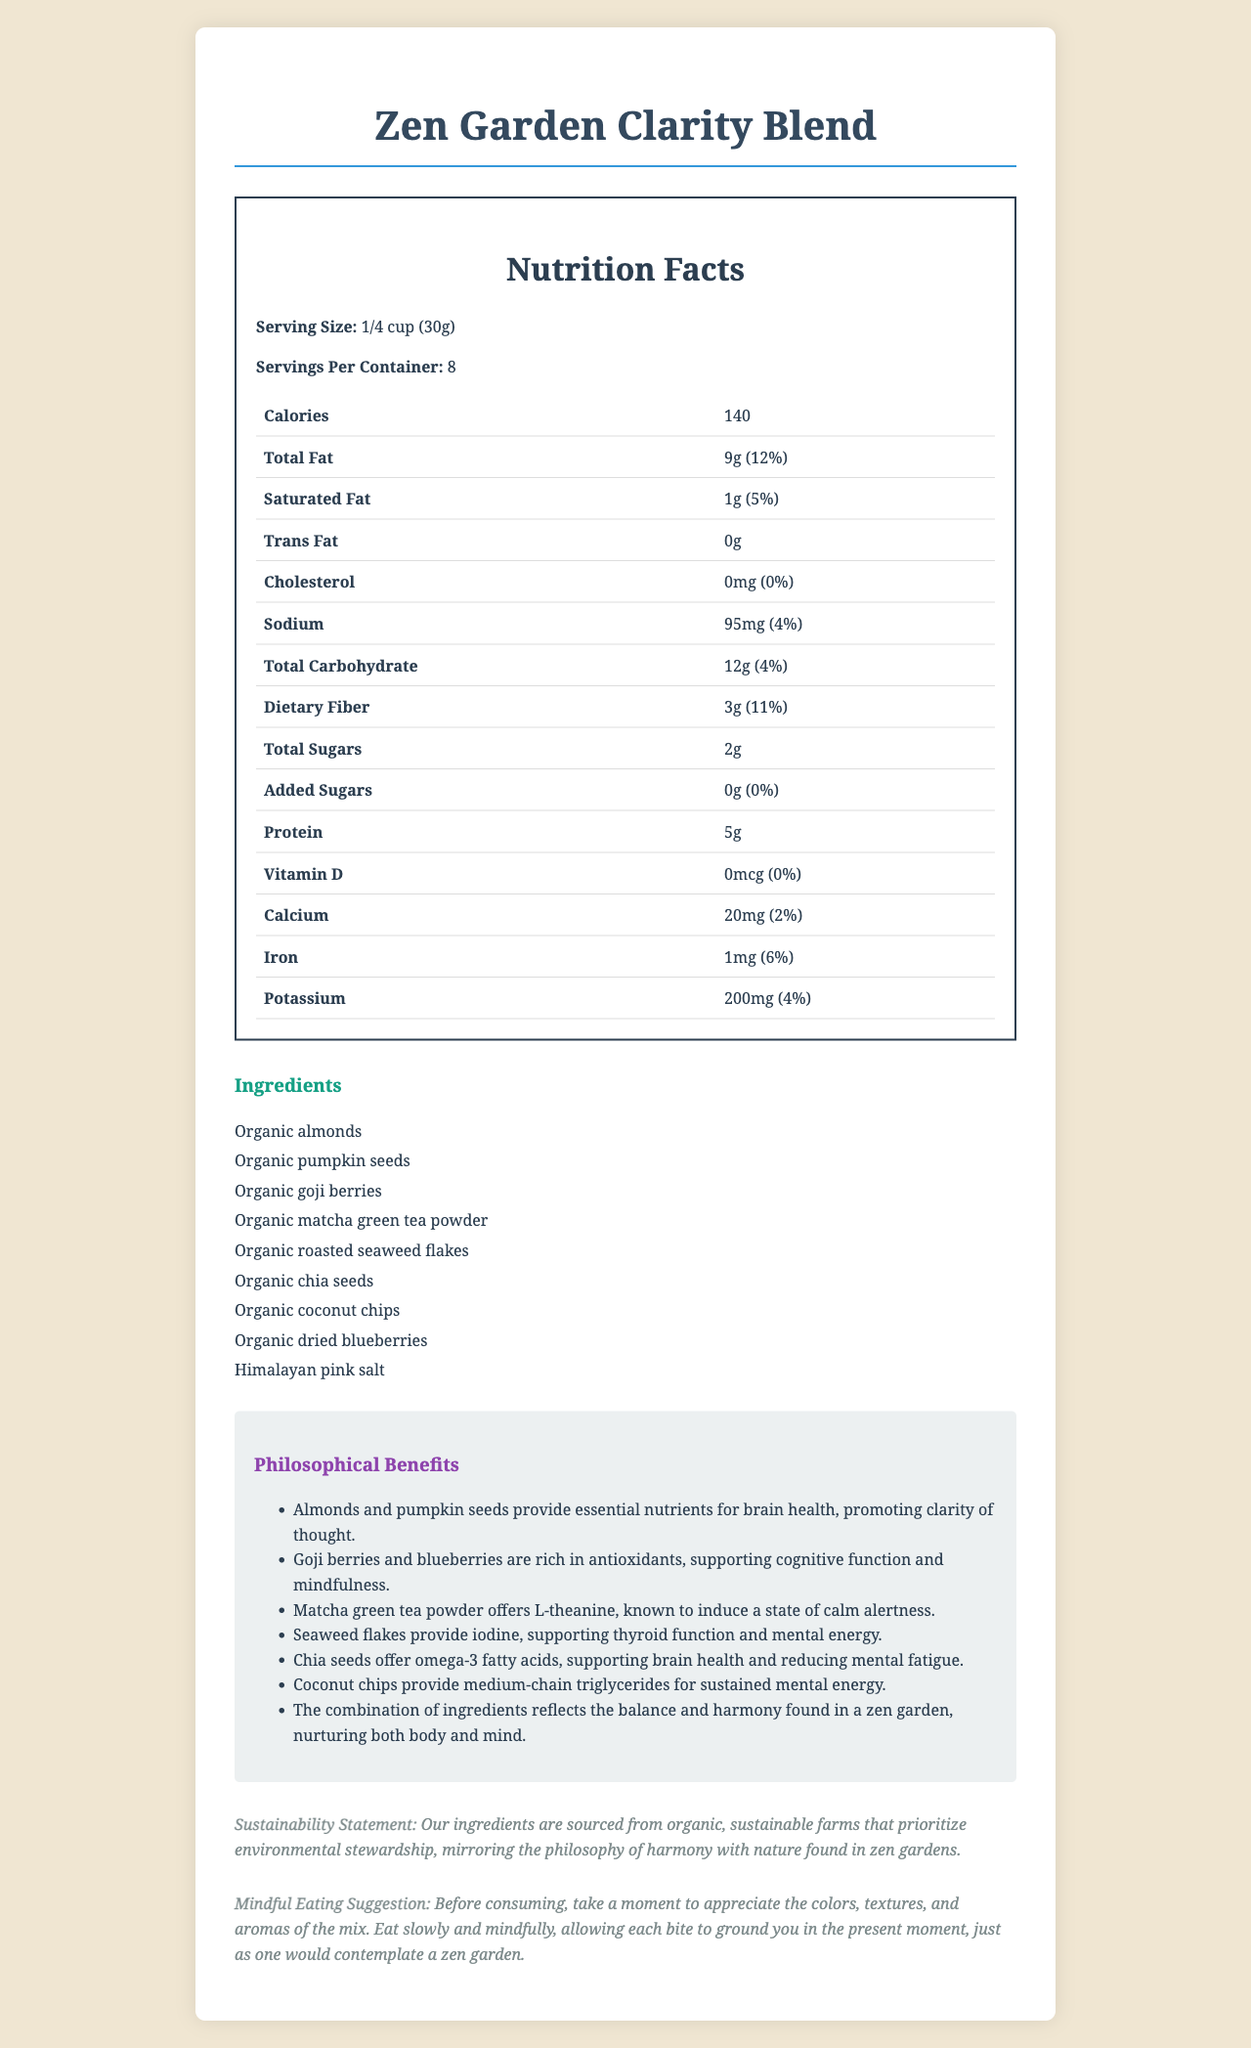what is the serving size? The serving size is explicitly mentioned as "1/4 cup (30g)" in the nutrition facts.
Answer: 1/4 cup (30g) how many calories are in a single serving? The document lists the calories per serving as 140.
Answer: 140 how much total fat does each serving contain? The nutrition label states that each serving contains 9 grams of total fat.
Answer: 9g what is the daily value percentage of dietary fiber in one serving? The daily value of dietary fiber per serving is listed as 11%.
Answer: 11% how many servings are there in a container? The document specifies that there are 8 servings per container.
Answer: 8 which of the following ingredients is not included in the Zen Garden Clarity Blend? A. Almonds B. Pumpkin seeds C. Cashews D. Matcha green tea powder The listed ingredients include almonds, pumpkin seeds, and matcha green tea powder, but not cashews.
Answer: C what is the primary purpose of adding matcha green tea powder to the snack mix? A. Adding sweetness B. Inducing calm alertness C. Enhancing flavor D. Increasing protein The document states that matcha green tea powder offers L-theanine, known to induce a state of calm alertness.
Answer: B does the product contain any added sugars? The nutrition label shows that there are 0 grams of added sugars, meaning the product contains no added sugars.
Answer: No is the snack mix free of cholesterol? The nutrition facts indicate that the product contains 0 mg of cholesterol, which is 0% of the daily value.
Answer: Yes summarize the overall nutritional and philosophical benefits of the Zen Garden Clarity Blend. The document describes the nutritional values and philosophical benefits of the blend, highlighting ingredients that promote focus, clarity, and mindfulness, and their alignment with the principles of a zen garden.
Answer: The Zen Garden Clarity Blend offers nutrients that support brain health, clarity of thought, and cognitive function while promoting mindfulness and calm alertness. Its organic ingredients, high in antioxidants, omega-3s, and essential minerals, support overall mental energy and health, reflecting the balance and harmony of a zen garden. what is the exact amount of vitamin D in the snack mix? The amount of vitamin D is listed as 0 mcg, with no relevant detail beyond stating it fulfills 0% of the daily value. There isn’t enough information to understand any trace presence.
Answer: Cannot be determined 